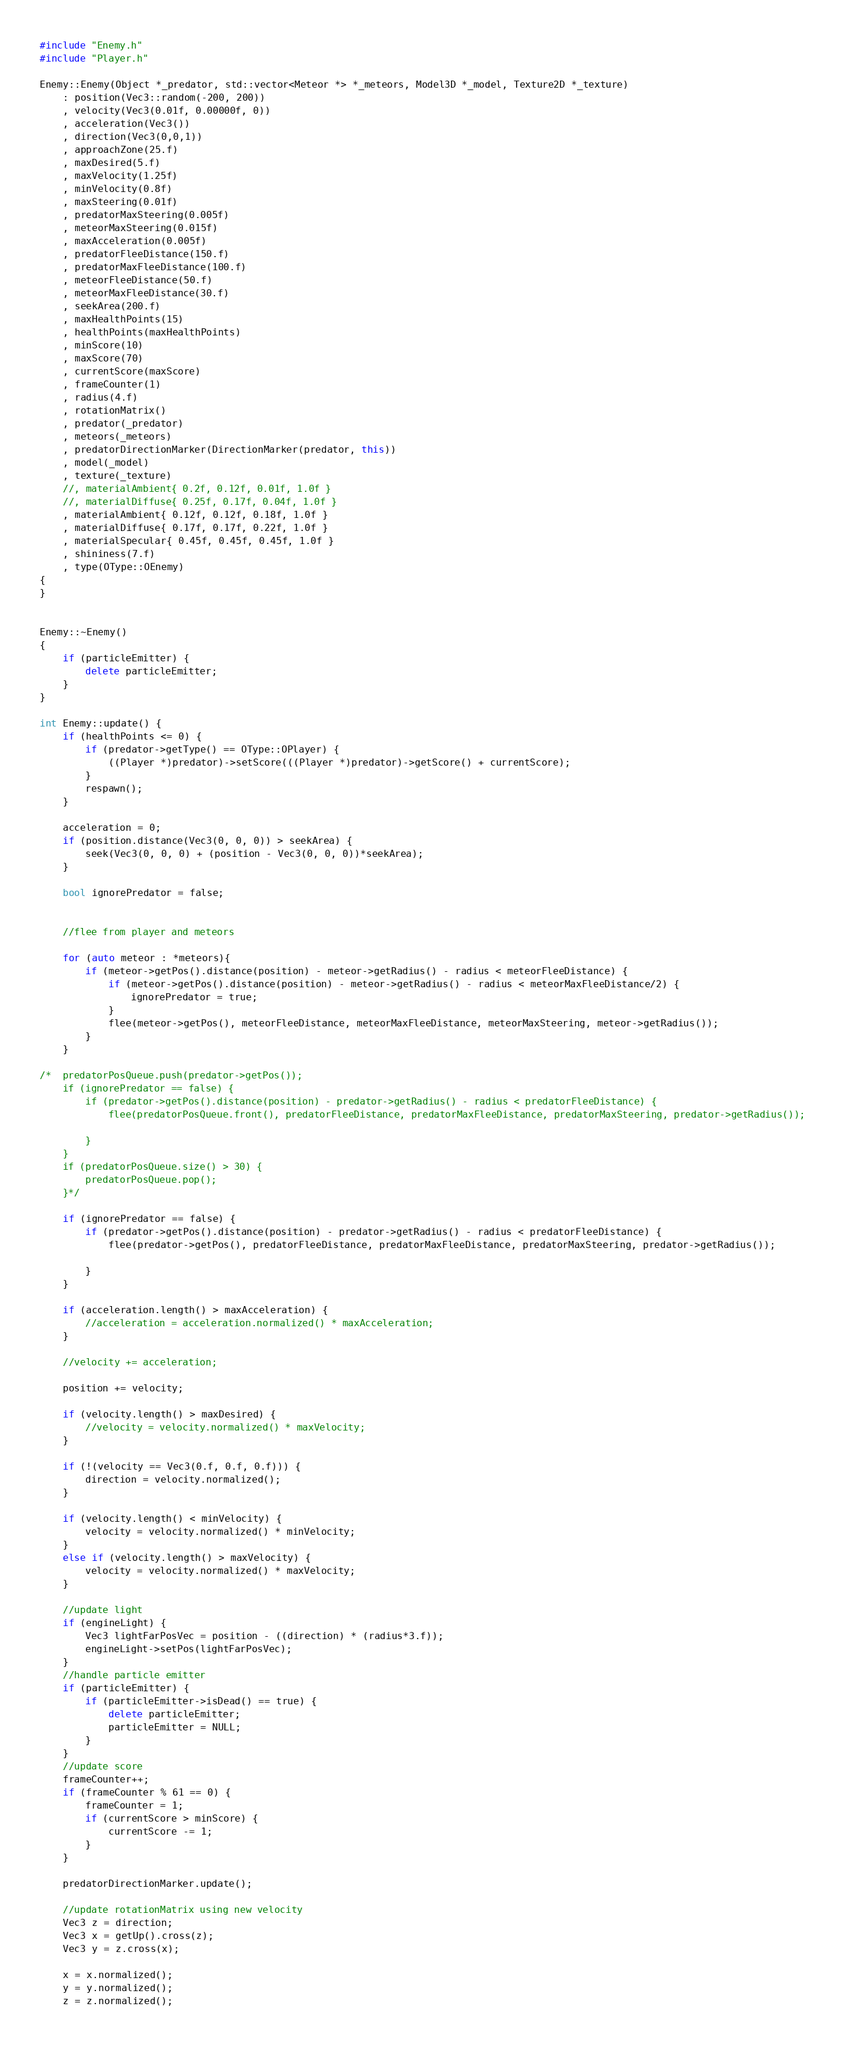<code> <loc_0><loc_0><loc_500><loc_500><_C++_>#include "Enemy.h"
#include "Player.h"

Enemy::Enemy(Object *_predator, std::vector<Meteor *> *_meteors, Model3D *_model, Texture2D *_texture)
	: position(Vec3::random(-200, 200))
	, velocity(Vec3(0.01f, 0.00000f, 0))
	, acceleration(Vec3())
	, direction(Vec3(0,0,1))
	, approachZone(25.f)
	, maxDesired(5.f)
	, maxVelocity(1.25f)
	, minVelocity(0.8f)
	, maxSteering(0.01f)
	, predatorMaxSteering(0.005f)
	, meteorMaxSteering(0.015f)
	, maxAcceleration(0.005f)
	, predatorFleeDistance(150.f)
	, predatorMaxFleeDistance(100.f)
	, meteorFleeDistance(50.f)
	, meteorMaxFleeDistance(30.f)
	, seekArea(200.f)
	, maxHealthPoints(15)
	, healthPoints(maxHealthPoints)
	, minScore(10)
	, maxScore(70)
	, currentScore(maxScore)
	, frameCounter(1)
	, radius(4.f)
	, rotationMatrix()
	, predator(_predator)
	, meteors(_meteors)
	, predatorDirectionMarker(DirectionMarker(predator, this))
	, model(_model)
	, texture(_texture)
	//, materialAmbient{ 0.2f, 0.12f, 0.01f, 1.0f }
	//, materialDiffuse{ 0.25f, 0.17f, 0.04f, 1.0f }
	, materialAmbient{ 0.12f, 0.12f, 0.18f, 1.0f }
	, materialDiffuse{ 0.17f, 0.17f, 0.22f, 1.0f }
	, materialSpecular{ 0.45f, 0.45f, 0.45f, 1.0f }
	, shininess(7.f)
	, type(OType::OEnemy)
{
}


Enemy::~Enemy()
{
	if (particleEmitter) {
		delete particleEmitter;
	}
}

int Enemy::update() {
	if (healthPoints <= 0) {
		if (predator->getType() == OType::OPlayer) {
			((Player *)predator)->setScore(((Player *)predator)->getScore() + currentScore);
		}
		respawn();
	}

	acceleration = 0;
	if (position.distance(Vec3(0, 0, 0)) > seekArea) {
		seek(Vec3(0, 0, 0) + (position - Vec3(0, 0, 0))*seekArea);
	}

	bool ignorePredator = false;
	

	//flee from player and meteors

	for (auto meteor : *meteors){
		if (meteor->getPos().distance(position) - meteor->getRadius() - radius < meteorFleeDistance) {
			if (meteor->getPos().distance(position) - meteor->getRadius() - radius < meteorMaxFleeDistance/2) {
				ignorePredator = true;
			}
			flee(meteor->getPos(), meteorFleeDistance, meteorMaxFleeDistance, meteorMaxSteering, meteor->getRadius());
		}
	}
	
/*	predatorPosQueue.push(predator->getPos());
	if (ignorePredator == false) {
		if (predator->getPos().distance(position) - predator->getRadius() - radius < predatorFleeDistance) {
			flee(predatorPosQueue.front(), predatorFleeDistance, predatorMaxFleeDistance, predatorMaxSteering, predator->getRadius());
			
		}
	}
	if (predatorPosQueue.size() > 30) {
		predatorPosQueue.pop();
	}*/

	if (ignorePredator == false) {
		if (predator->getPos().distance(position) - predator->getRadius() - radius < predatorFleeDistance) {
			flee(predator->getPos(), predatorFleeDistance, predatorMaxFleeDistance, predatorMaxSteering, predator->getRadius());

		}
	}

	if (acceleration.length() > maxAcceleration) {
		//acceleration = acceleration.normalized() * maxAcceleration;
	}

	//velocity += acceleration;

	position += velocity;

	if (velocity.length() > maxDesired) {
		//velocity = velocity.normalized() * maxVelocity;
	}

	if (!(velocity == Vec3(0.f, 0.f, 0.f))) {
		direction = velocity.normalized();
	}

	if (velocity.length() < minVelocity) {
		velocity = velocity.normalized() * minVelocity;
	}
	else if (velocity.length() > maxVelocity) {
		velocity = velocity.normalized() * maxVelocity;
	}

	//update light
	if (engineLight) {
		Vec3 lightFarPosVec = position - ((direction) * (radius*3.f));
		engineLight->setPos(lightFarPosVec);
	}
	//handle particle emitter
	if (particleEmitter) {
		if (particleEmitter->isDead() == true) {
			delete particleEmitter;
			particleEmitter = NULL;
		}
	}
	//update score
	frameCounter++;
	if (frameCounter % 61 == 0) {
		frameCounter = 1;
		if (currentScore > minScore) {
			currentScore -= 1;
		}
	}

	predatorDirectionMarker.update();

	//update rotationMatrix using new velocity
	Vec3 z = direction;
	Vec3 x = getUp().cross(z);
	Vec3 y = z.cross(x);

	x = x.normalized();
	y = y.normalized();
	z = z.normalized();
</code> 